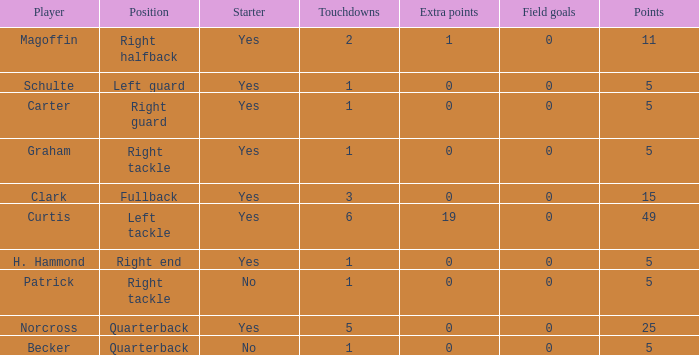Name the most field goals 0.0. 